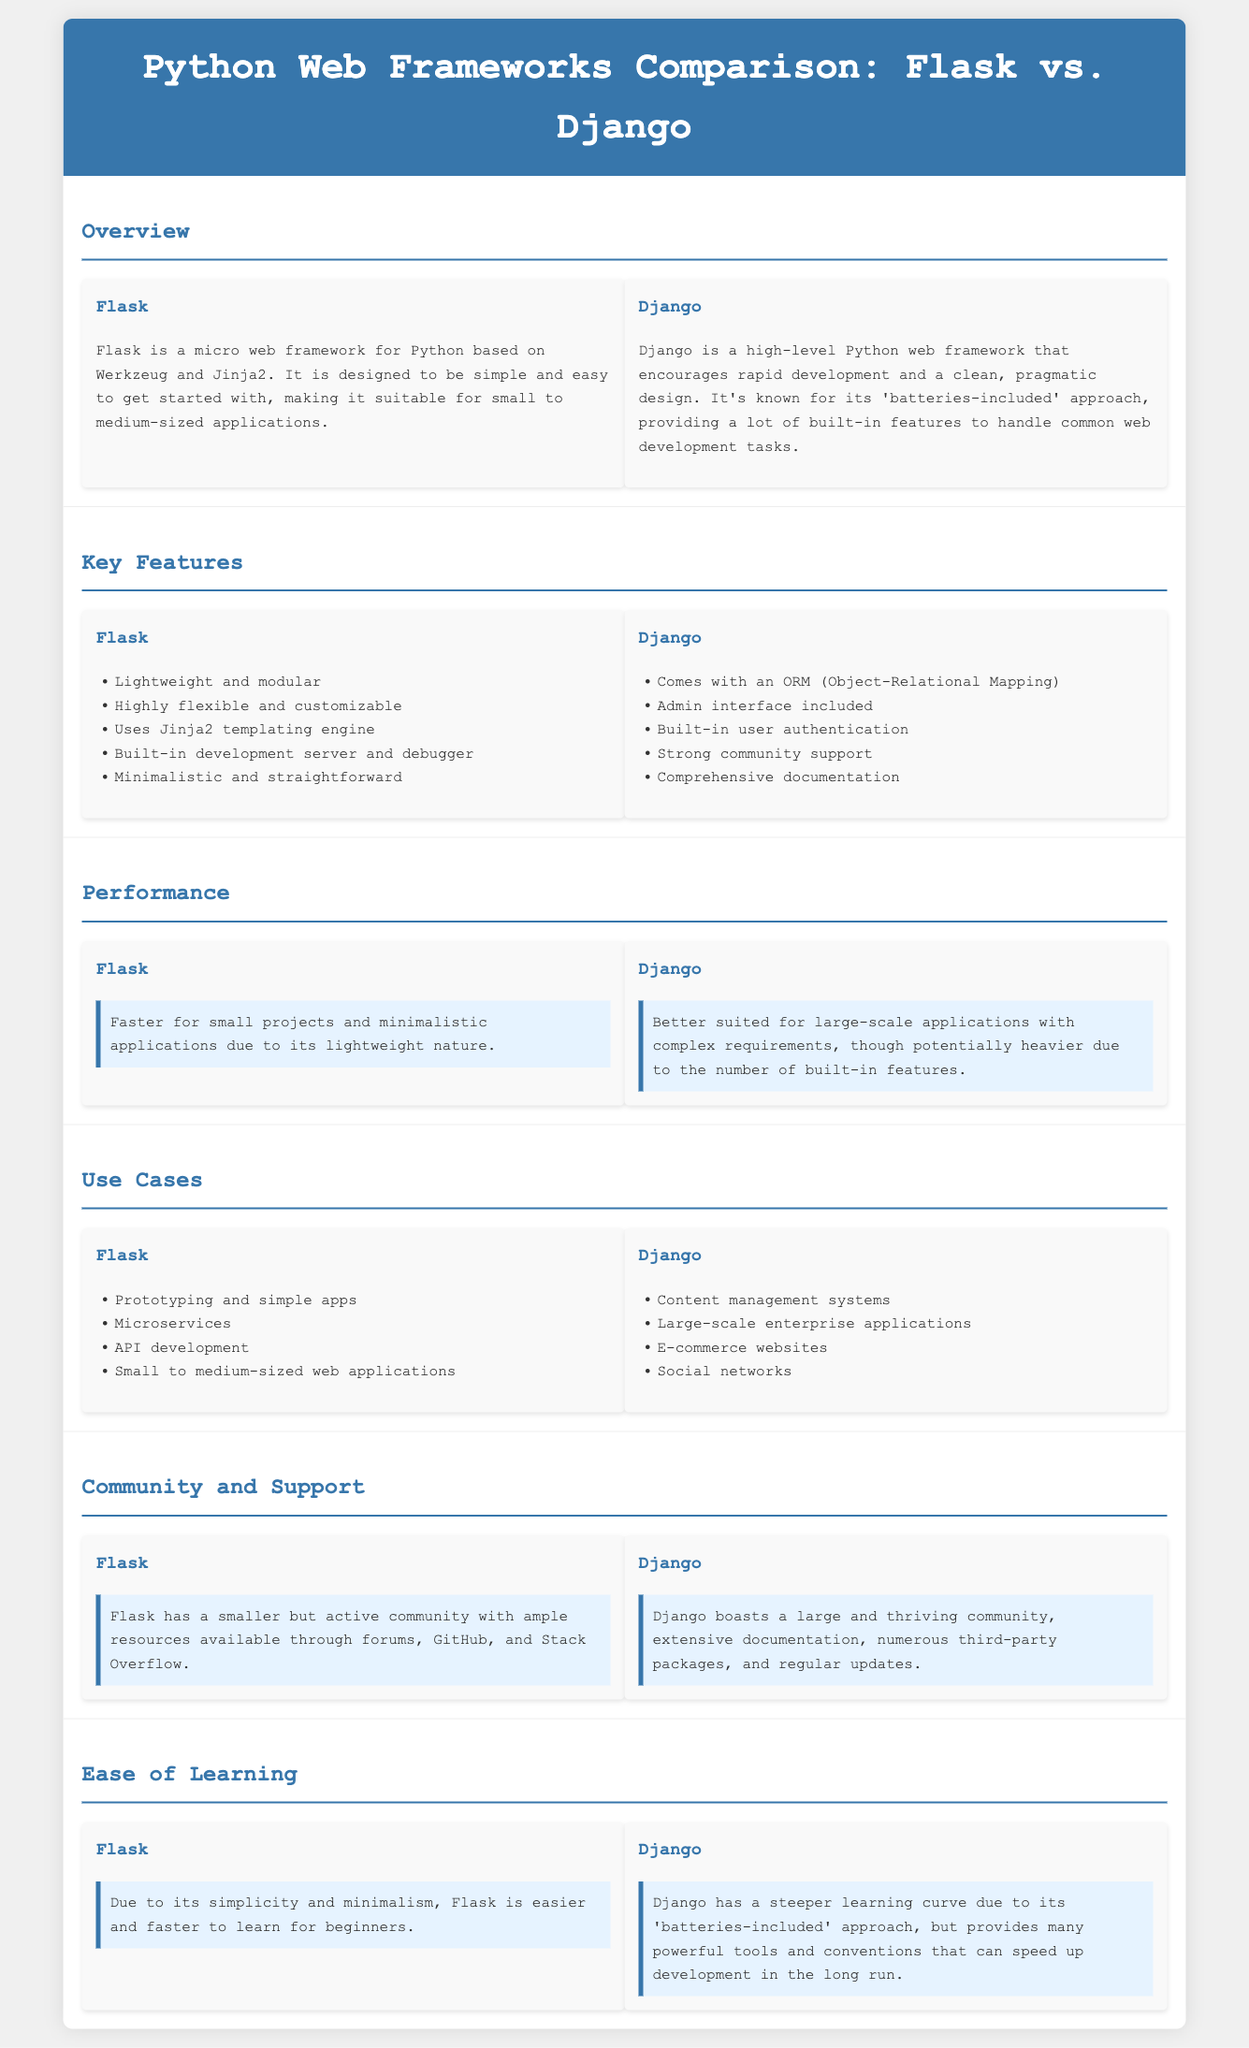What is Flask? Flask is a micro web framework for Python based on Werkzeug and Jinja2.
Answer: micro web framework What is Django known for? Django is known for its 'batteries-included' approach, providing many built-in features.
Answer: 'batteries-included' approach Which templating engine does Flask use? Flask uses the Jinja2 templating engine for rendering web pages.
Answer: Jinja2 What type of applications is Flask better suited for? Flask is suited for small projects and minimalistic applications due to its lightweight nature.
Answer: small projects What technological feature does Django offer that Flask does not? Django comes with an ORM (Object-Relational Mapping) for database interactions.
Answer: ORM Which web framework has a steeper learning curve? Django has a steeper learning curve due to its comprehensive features.
Answer: Django What kind of support does the Django community provide? Django boasts a large community with extensive documentation and numerous third-party packages.
Answer: large community What types of projects can Flask be used for? Flask can be used for prototyping, microservices, and small to medium-sized web applications.
Answer: prototyping Which web framework is easier for beginners to learn? Flask is easier and faster to learn for beginners due to its simplicity.
Answer: Flask 